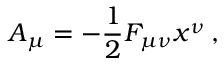<formula> <loc_0><loc_0><loc_500><loc_500>A _ { \mu } = - \frac { 1 } { 2 } F _ { \mu \nu } x ^ { \nu } \, ,</formula> 